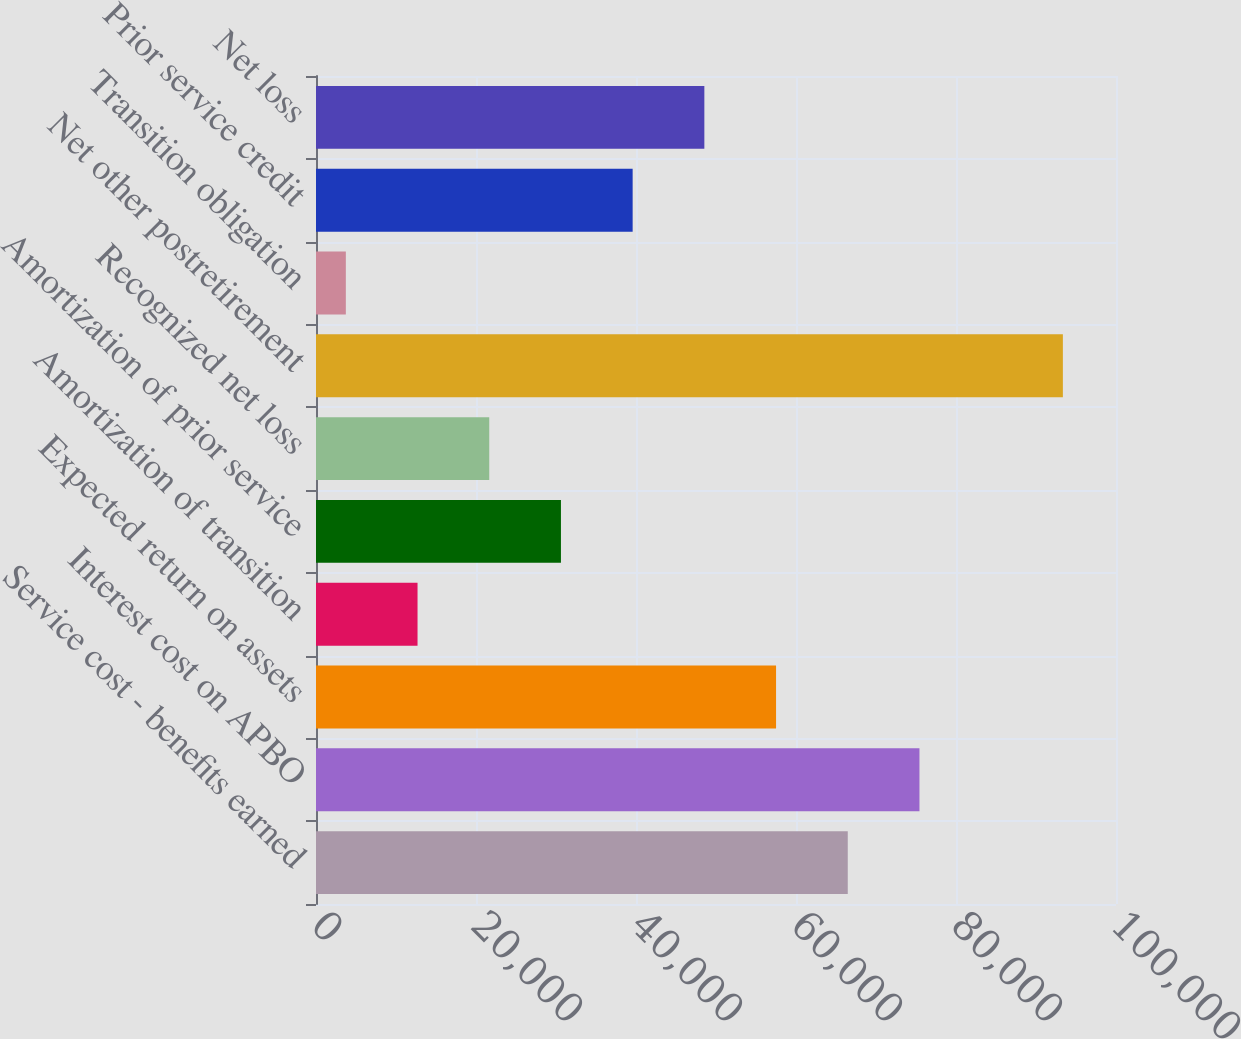Convert chart. <chart><loc_0><loc_0><loc_500><loc_500><bar_chart><fcel>Service cost - benefits earned<fcel>Interest cost on APBO<fcel>Expected return on assets<fcel>Amortization of transition<fcel>Amortization of prior service<fcel>Recognized net loss<fcel>Net other postretirement<fcel>Transition obligation<fcel>Prior service credit<fcel>Net loss<nl><fcel>66470<fcel>75433<fcel>57507<fcel>12692<fcel>30618<fcel>21655<fcel>93359<fcel>3729<fcel>39581<fcel>48544<nl></chart> 